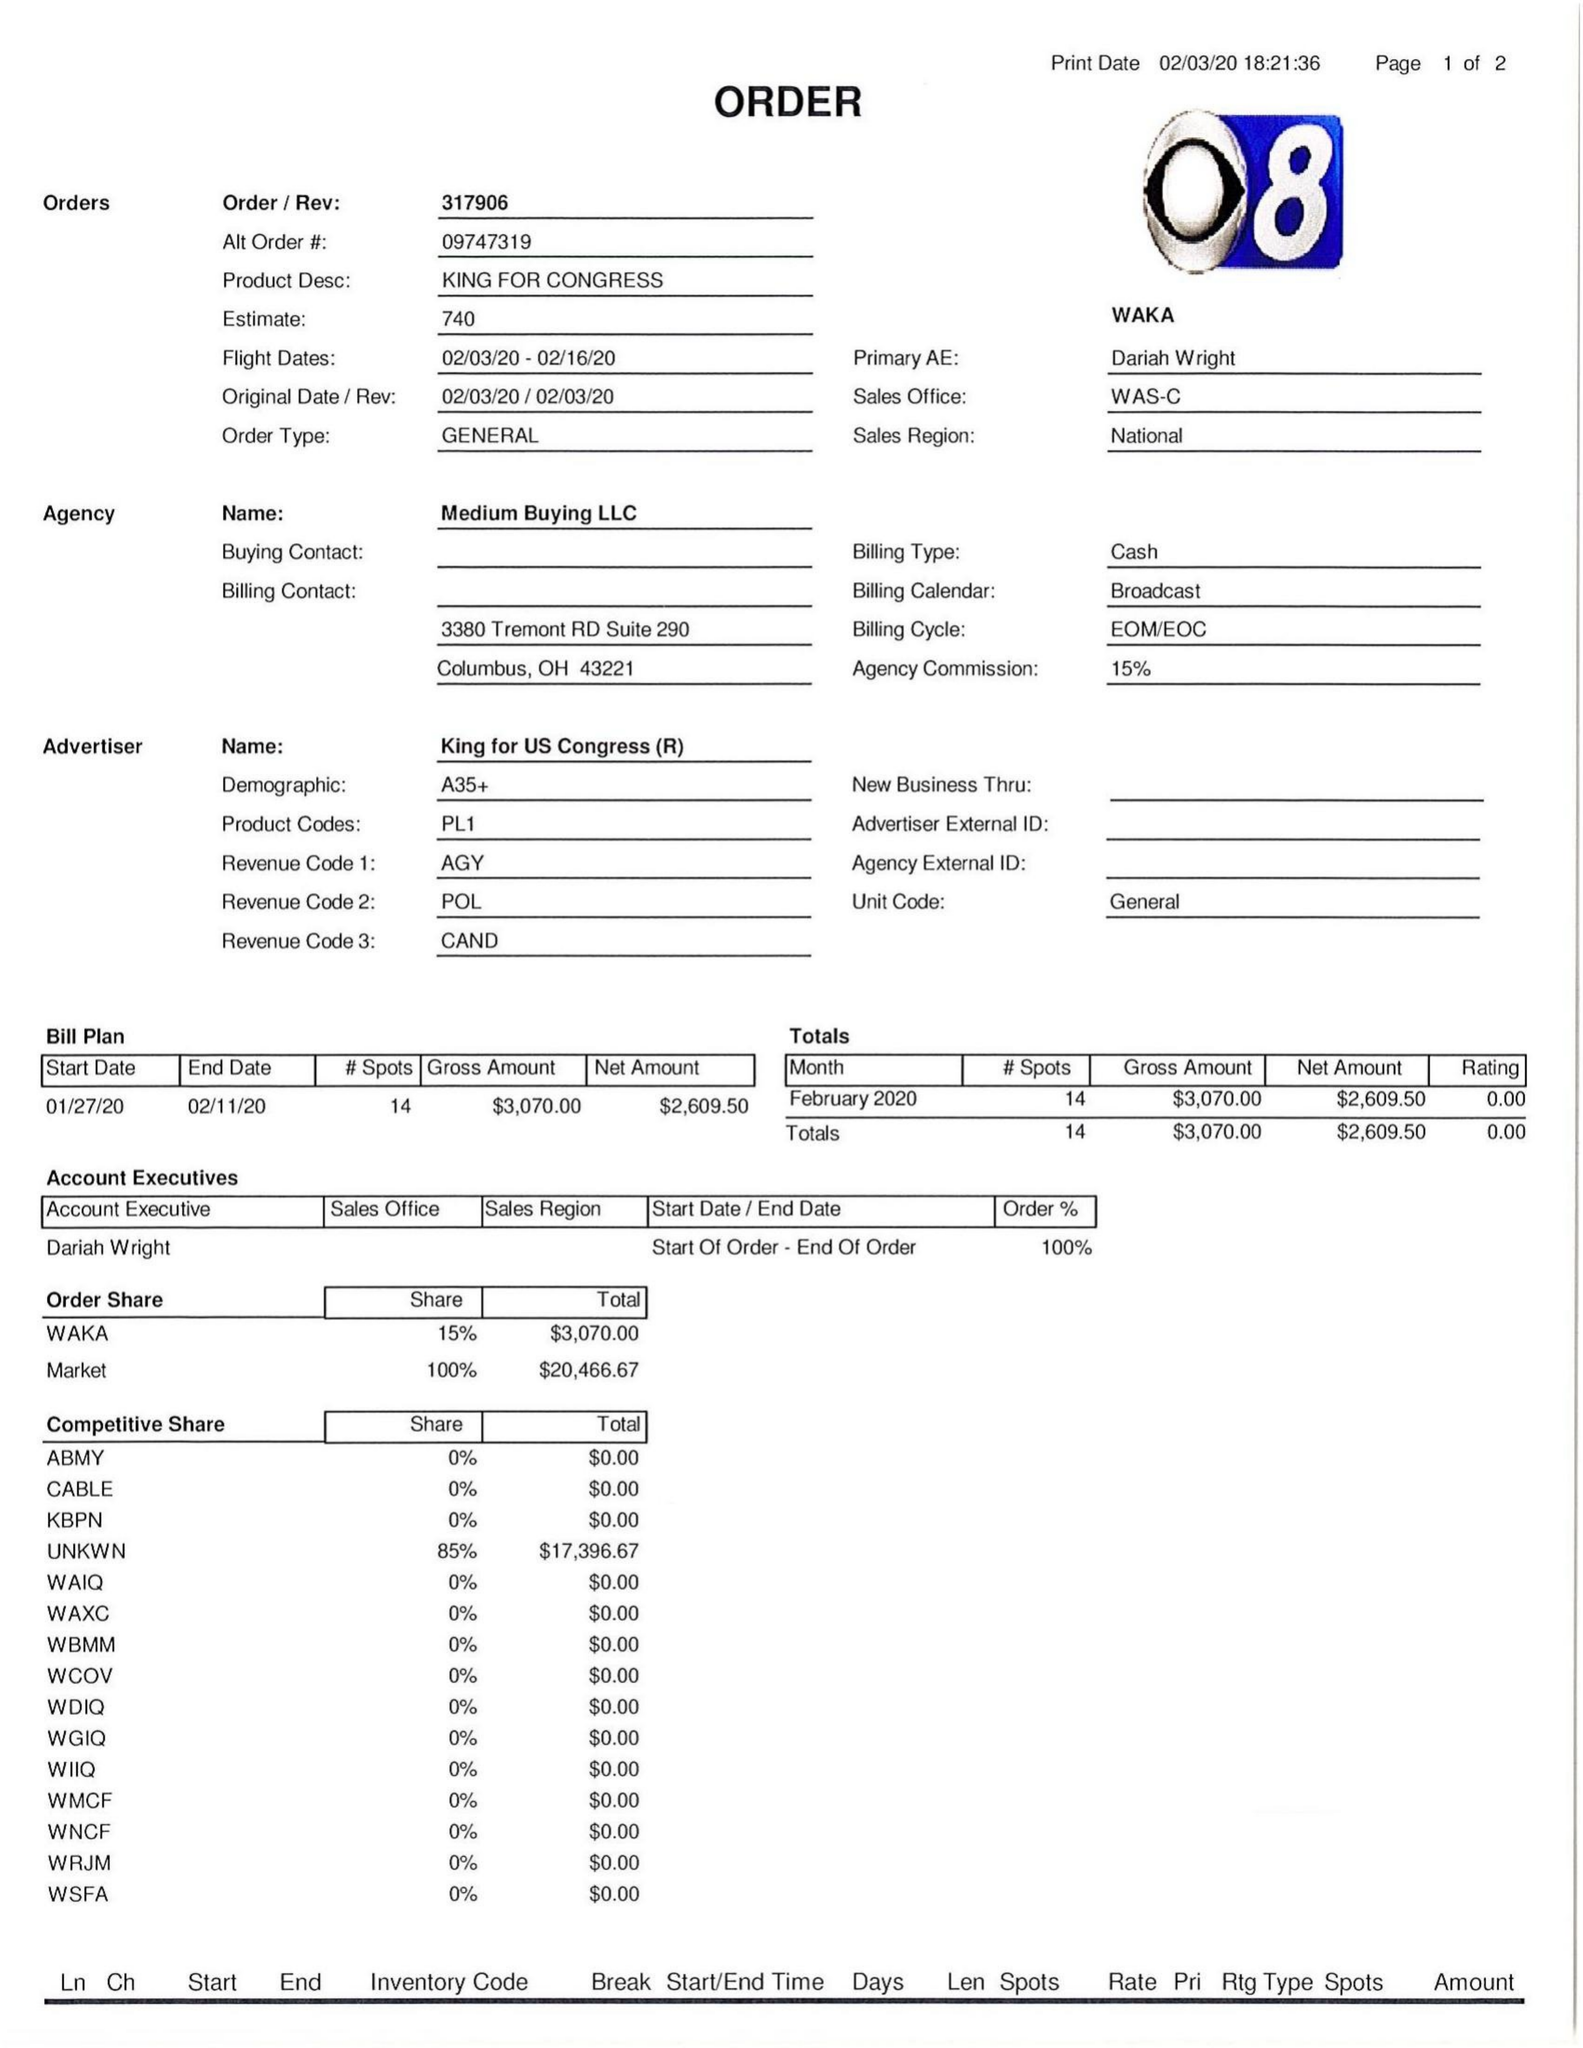What is the value for the contract_num?
Answer the question using a single word or phrase. 317906 